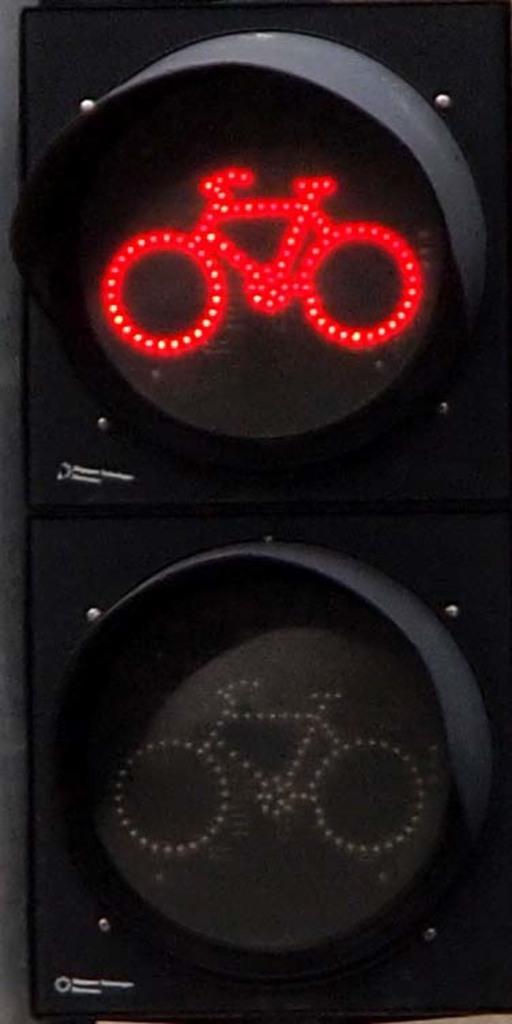How would you summarize this image in a sentence or two? In the center of this picture we can see the traffic signal and we can see the depictions of bicycles and some other objects. 